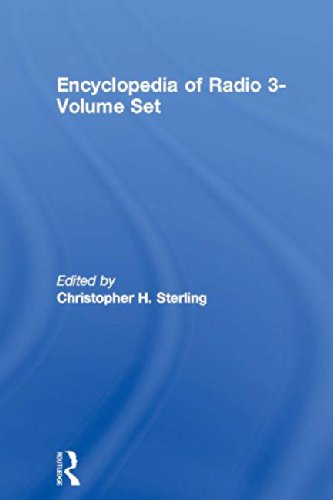What time period does this encyclopedia cover about the development of radio? This encyclopedia covers the development of radio from its inception in the late 19th century up to contemporary times, providing insights into over a century of radio technology evolution. 